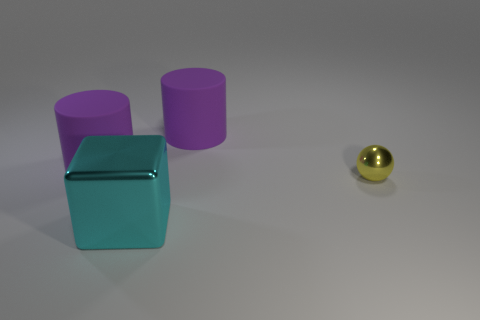Add 2 blocks. How many objects exist? 6 Add 3 big gray metal spheres. How many big gray metal spheres exist? 3 Subtract 0 gray balls. How many objects are left? 4 Subtract all balls. How many objects are left? 3 Subtract all blue spheres. Subtract all cyan cylinders. How many spheres are left? 1 Subtract all gray metal cylinders. Subtract all tiny yellow shiny objects. How many objects are left? 3 Add 4 big matte cylinders. How many big matte cylinders are left? 6 